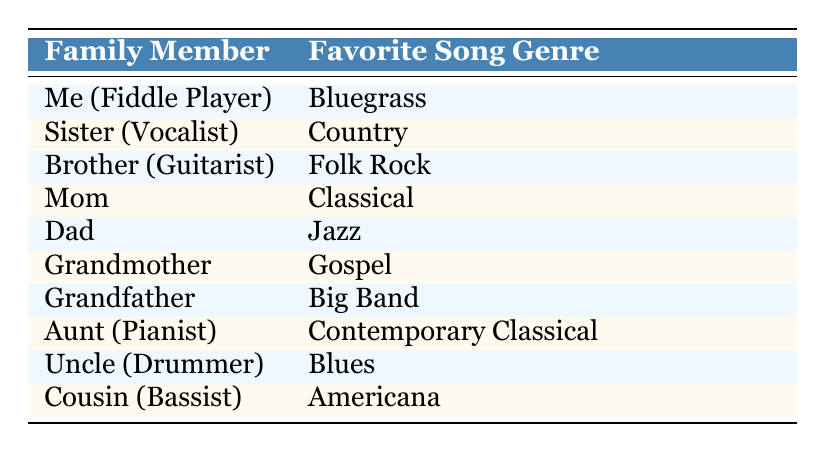What is your favorite song genre? Your favorite song genre, as a fiddle player, is listed in the table as "Bluegrass."
Answer: Bluegrass Which family member enjoys Jazz? The table shows that the family member who enjoys Jazz is "Dad."
Answer: Dad How many family members prefer song genres that are common in American music? The family members who prefer American music genres are Sister (Country), Uncle (Blues), and Cousin (Americana), which totals three members.
Answer: 3 Is there a family member who likes Classical music? Yes, the table indicates that "Mom" enjoys Classical music.
Answer: Yes Are there more family members who prefer genres that are instrumental than ones that are vocal-focused? If we categorize instrumental genres (Jazz, Classical, Big Band, Blues, Contemporary Classical) and vocal genres (Bluegrass, Country, Folk Rock, Gospel, Americana), there are 5 instrumental and 5 vocal, resulting in a tie.
Answer: No Which family member plays the guitar? The family member who plays the guitar is referred to as "Brother (Guitarist)."
Answer: Brother What are the favorite song genres of the oldest family member? The oldest family member, likely "Grandfather," enjoys "Big Band" music according to the table.
Answer: Big Band How many family members have a preference for genres that have their roots in African-American music styles? The genres rooted in African-American music include Jazz, Blues, and Gospel, which are appreciated by Dad, Uncle, and Grandmother respectively. Therefore, there are 3 family members.
Answer: 3 What percentage of family members prefer Folk-related genres? Folk-related genres include Folk Rock and Bluegrass, preferred by Brother and Me, respectively. Out of 10 family members, that is 2, which is 20%.
Answer: 20% 